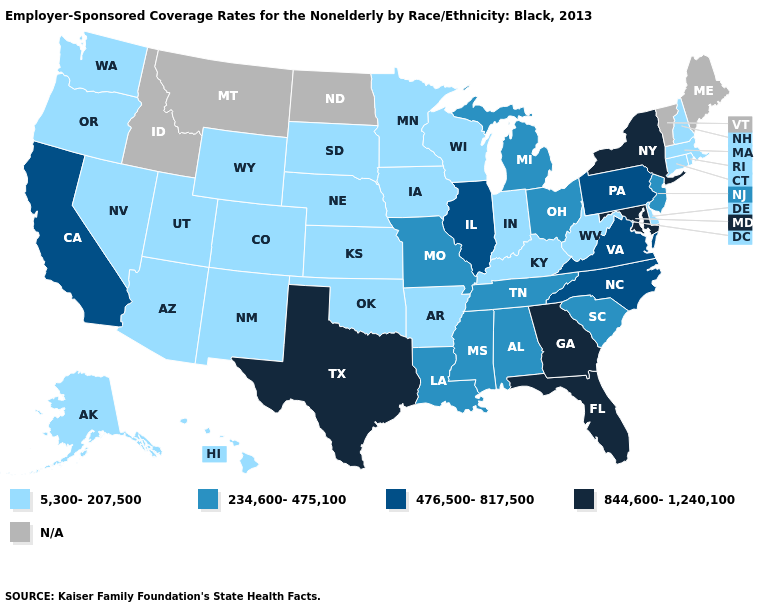Name the states that have a value in the range 234,600-475,100?
Quick response, please. Alabama, Louisiana, Michigan, Mississippi, Missouri, New Jersey, Ohio, South Carolina, Tennessee. What is the lowest value in the USA?
Give a very brief answer. 5,300-207,500. What is the lowest value in states that border Missouri?
Quick response, please. 5,300-207,500. Name the states that have a value in the range 234,600-475,100?
Be succinct. Alabama, Louisiana, Michigan, Mississippi, Missouri, New Jersey, Ohio, South Carolina, Tennessee. What is the lowest value in the Northeast?
Keep it brief. 5,300-207,500. Which states have the lowest value in the USA?
Concise answer only. Alaska, Arizona, Arkansas, Colorado, Connecticut, Delaware, Hawaii, Indiana, Iowa, Kansas, Kentucky, Massachusetts, Minnesota, Nebraska, Nevada, New Hampshire, New Mexico, Oklahoma, Oregon, Rhode Island, South Dakota, Utah, Washington, West Virginia, Wisconsin, Wyoming. What is the value of Montana?
Write a very short answer. N/A. Name the states that have a value in the range 5,300-207,500?
Keep it brief. Alaska, Arizona, Arkansas, Colorado, Connecticut, Delaware, Hawaii, Indiana, Iowa, Kansas, Kentucky, Massachusetts, Minnesota, Nebraska, Nevada, New Hampshire, New Mexico, Oklahoma, Oregon, Rhode Island, South Dakota, Utah, Washington, West Virginia, Wisconsin, Wyoming. Name the states that have a value in the range 5,300-207,500?
Concise answer only. Alaska, Arizona, Arkansas, Colorado, Connecticut, Delaware, Hawaii, Indiana, Iowa, Kansas, Kentucky, Massachusetts, Minnesota, Nebraska, Nevada, New Hampshire, New Mexico, Oklahoma, Oregon, Rhode Island, South Dakota, Utah, Washington, West Virginia, Wisconsin, Wyoming. Among the states that border Rhode Island , which have the highest value?
Short answer required. Connecticut, Massachusetts. What is the lowest value in the MidWest?
Concise answer only. 5,300-207,500. Name the states that have a value in the range 5,300-207,500?
Be succinct. Alaska, Arizona, Arkansas, Colorado, Connecticut, Delaware, Hawaii, Indiana, Iowa, Kansas, Kentucky, Massachusetts, Minnesota, Nebraska, Nevada, New Hampshire, New Mexico, Oklahoma, Oregon, Rhode Island, South Dakota, Utah, Washington, West Virginia, Wisconsin, Wyoming. Name the states that have a value in the range 5,300-207,500?
Quick response, please. Alaska, Arizona, Arkansas, Colorado, Connecticut, Delaware, Hawaii, Indiana, Iowa, Kansas, Kentucky, Massachusetts, Minnesota, Nebraska, Nevada, New Hampshire, New Mexico, Oklahoma, Oregon, Rhode Island, South Dakota, Utah, Washington, West Virginia, Wisconsin, Wyoming. What is the value of Indiana?
Keep it brief. 5,300-207,500. 